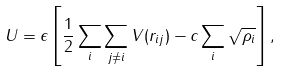<formula> <loc_0><loc_0><loc_500><loc_500>U & = \epsilon \left [ \frac { 1 } { 2 } \sum _ { i } \sum _ { j \ne i } V ( r _ { i j } ) - c \sum _ { i } \sqrt { \rho _ { i } } \right ] ,</formula> 